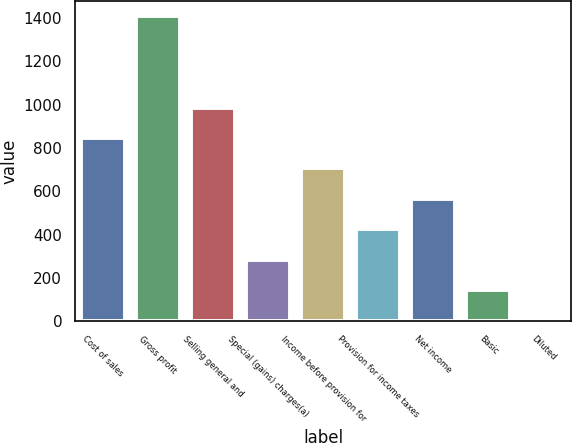Convert chart. <chart><loc_0><loc_0><loc_500><loc_500><bar_chart><fcel>Cost of sales<fcel>Gross profit<fcel>Selling general and<fcel>Special (gains) charges(a)<fcel>Income before provision for<fcel>Provision for income taxes<fcel>Net income<fcel>Basic<fcel>Diluted<nl><fcel>846.12<fcel>1408.6<fcel>986.73<fcel>283.68<fcel>705.51<fcel>424.29<fcel>564.9<fcel>143.07<fcel>2.46<nl></chart> 